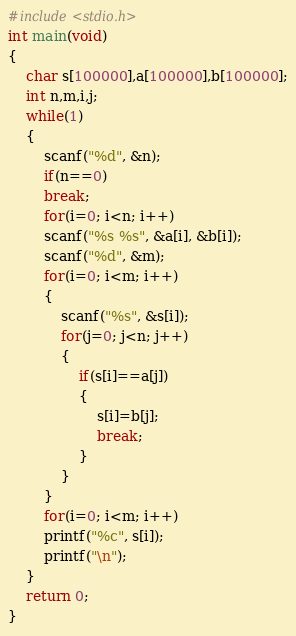Convert code to text. <code><loc_0><loc_0><loc_500><loc_500><_C_>#include<stdio.h>
int main(void)
{
	char s[100000],a[100000],b[100000];
	int n,m,i,j;
	while(1)
	{
		scanf("%d", &n);
		if(n==0)
		break;
		for(i=0; i<n; i++)
		scanf("%s %s", &a[i], &b[i]);
		scanf("%d", &m);
		for(i=0; i<m; i++)
		{
			scanf("%s", &s[i]);
			for(j=0; j<n; j++)
			{
				if(s[i]==a[j])
				{
					s[i]=b[j];
					break;
				}
			}
		}
		for(i=0; i<m; i++)
		printf("%c", s[i]);
		printf("\n");
	}
	return 0;
}
</code> 